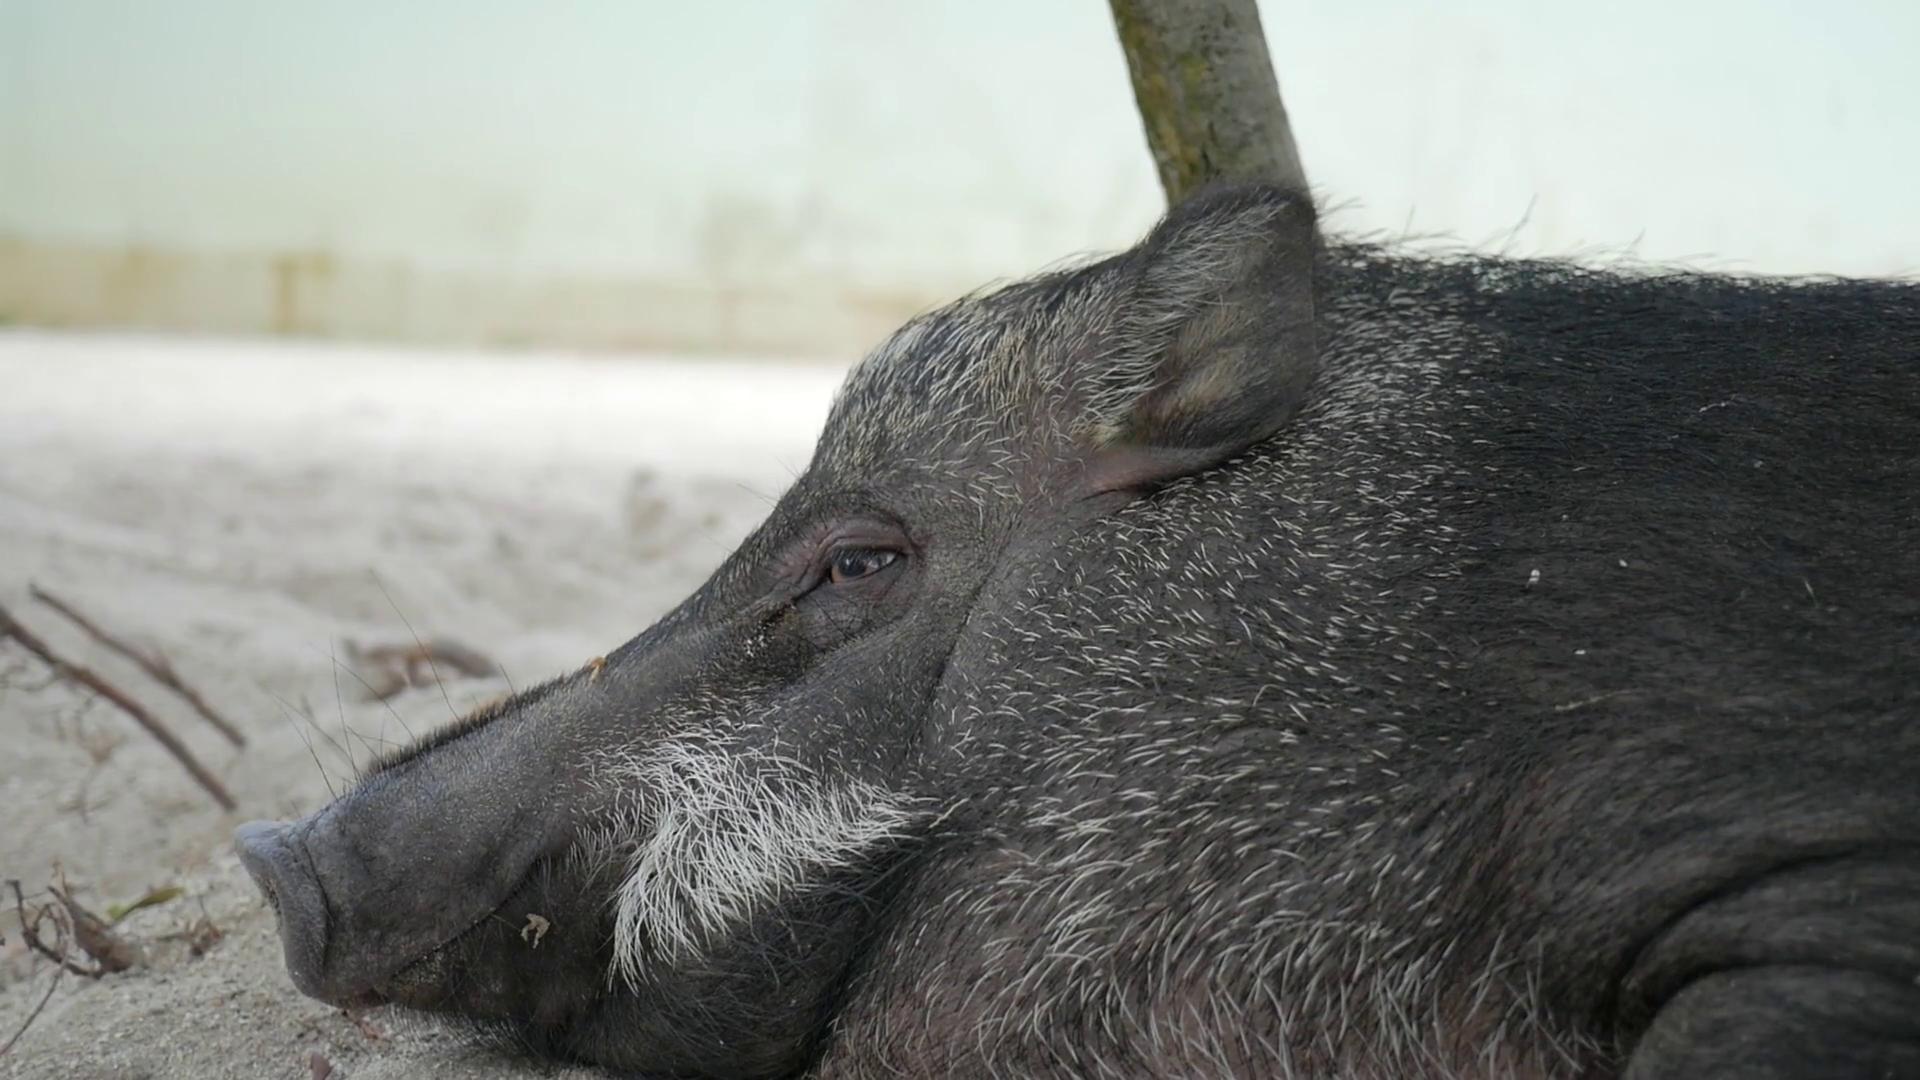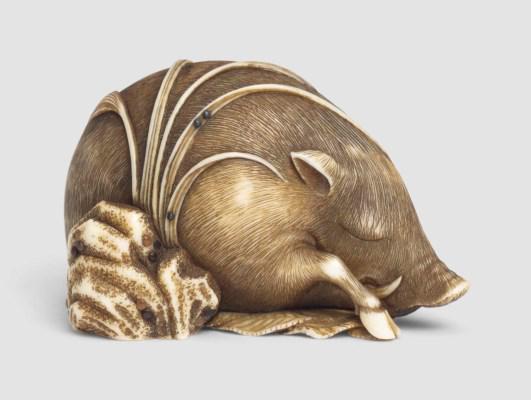The first image is the image on the left, the second image is the image on the right. Examine the images to the left and right. Is the description "There are two hogs in the pair of images." accurate? Answer yes or no. Yes. 